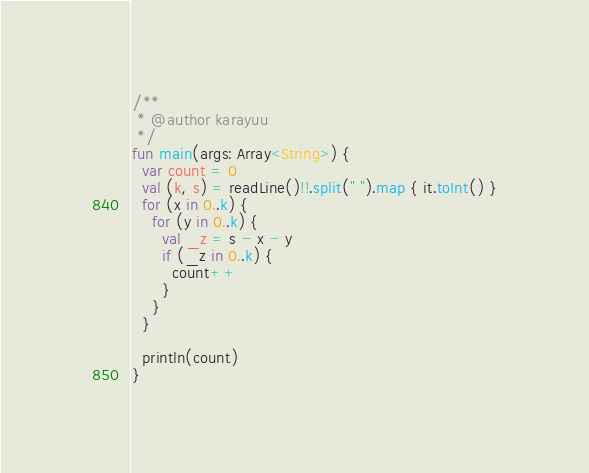<code> <loc_0><loc_0><loc_500><loc_500><_Kotlin_>/**
 * @author karayuu
 */
fun main(args: Array<String>) {
  var count = 0
  val (k, s) = readLine()!!.split(" ").map { it.toInt() }
  for (x in 0..k) {
    for (y in 0..k) {
      val _z = s - x - y
      if (_z in 0..k) {
        count++
      }
    }
  }

  println(count)
}</code> 